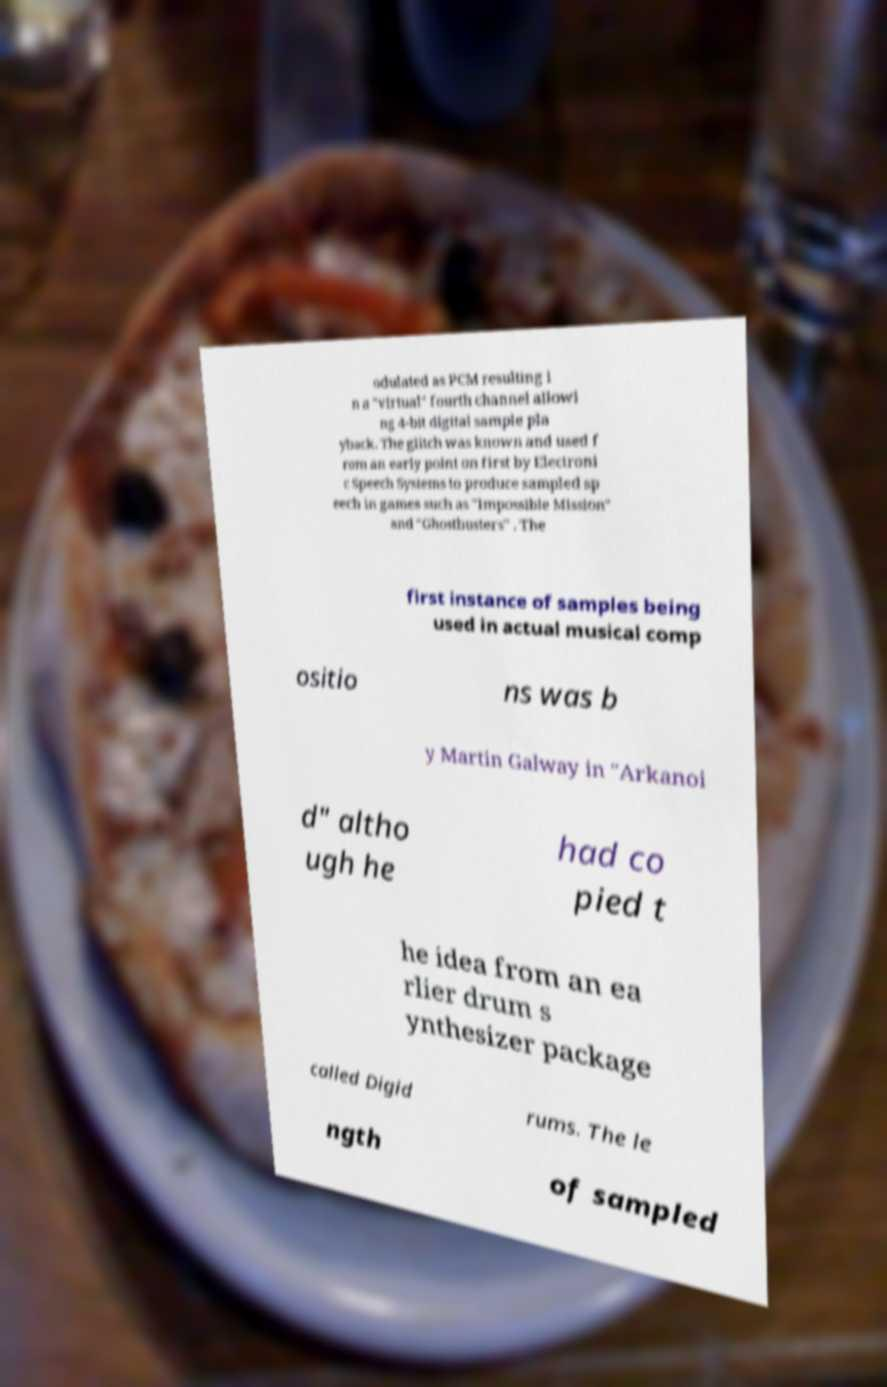Could you extract and type out the text from this image? odulated as PCM resulting i n a "virtual" fourth channel allowi ng 4-bit digital sample pla yback. The glitch was known and used f rom an early point on first by Electroni c Speech Systems to produce sampled sp eech in games such as "Impossible Mission" and "Ghostbusters" . The first instance of samples being used in actual musical comp ositio ns was b y Martin Galway in "Arkanoi d" altho ugh he had co pied t he idea from an ea rlier drum s ynthesizer package called Digid rums. The le ngth of sampled 